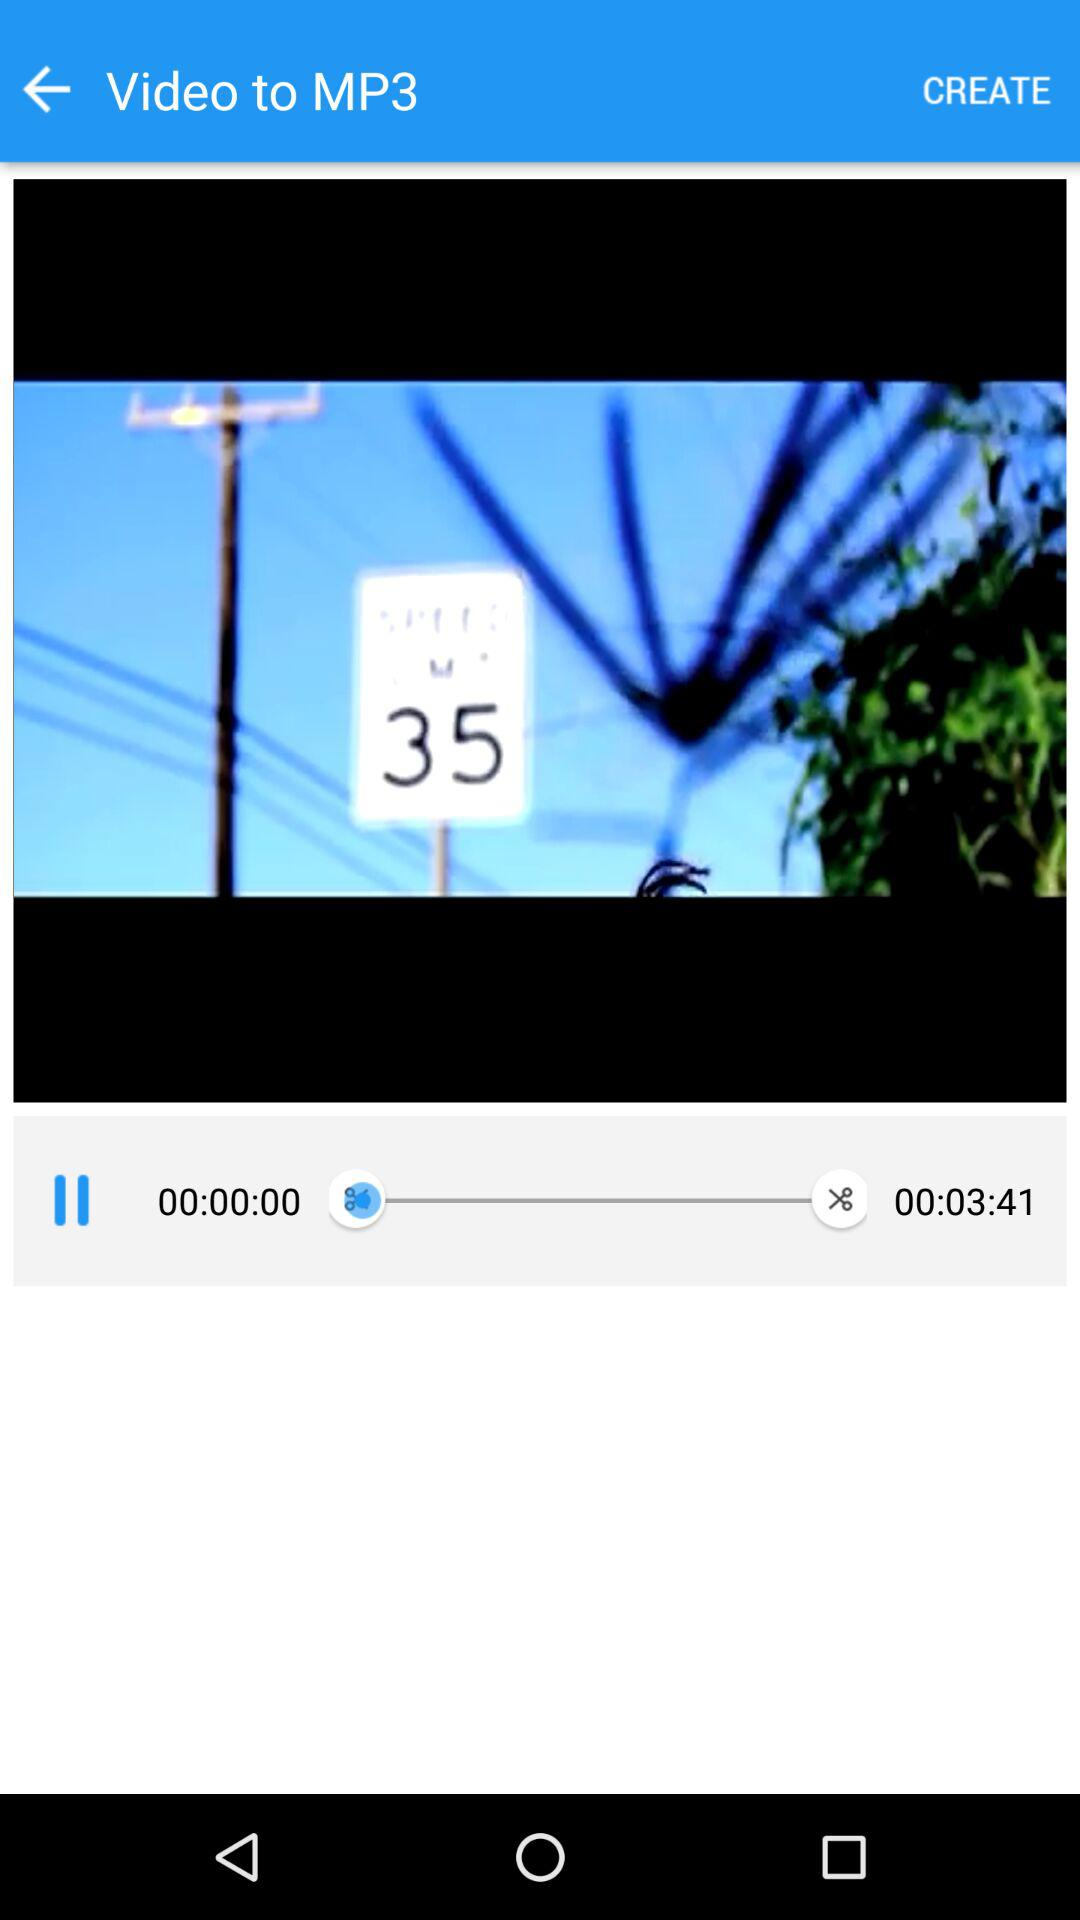What is the total duration? The total duration is 3 minutes 41 seconds. 